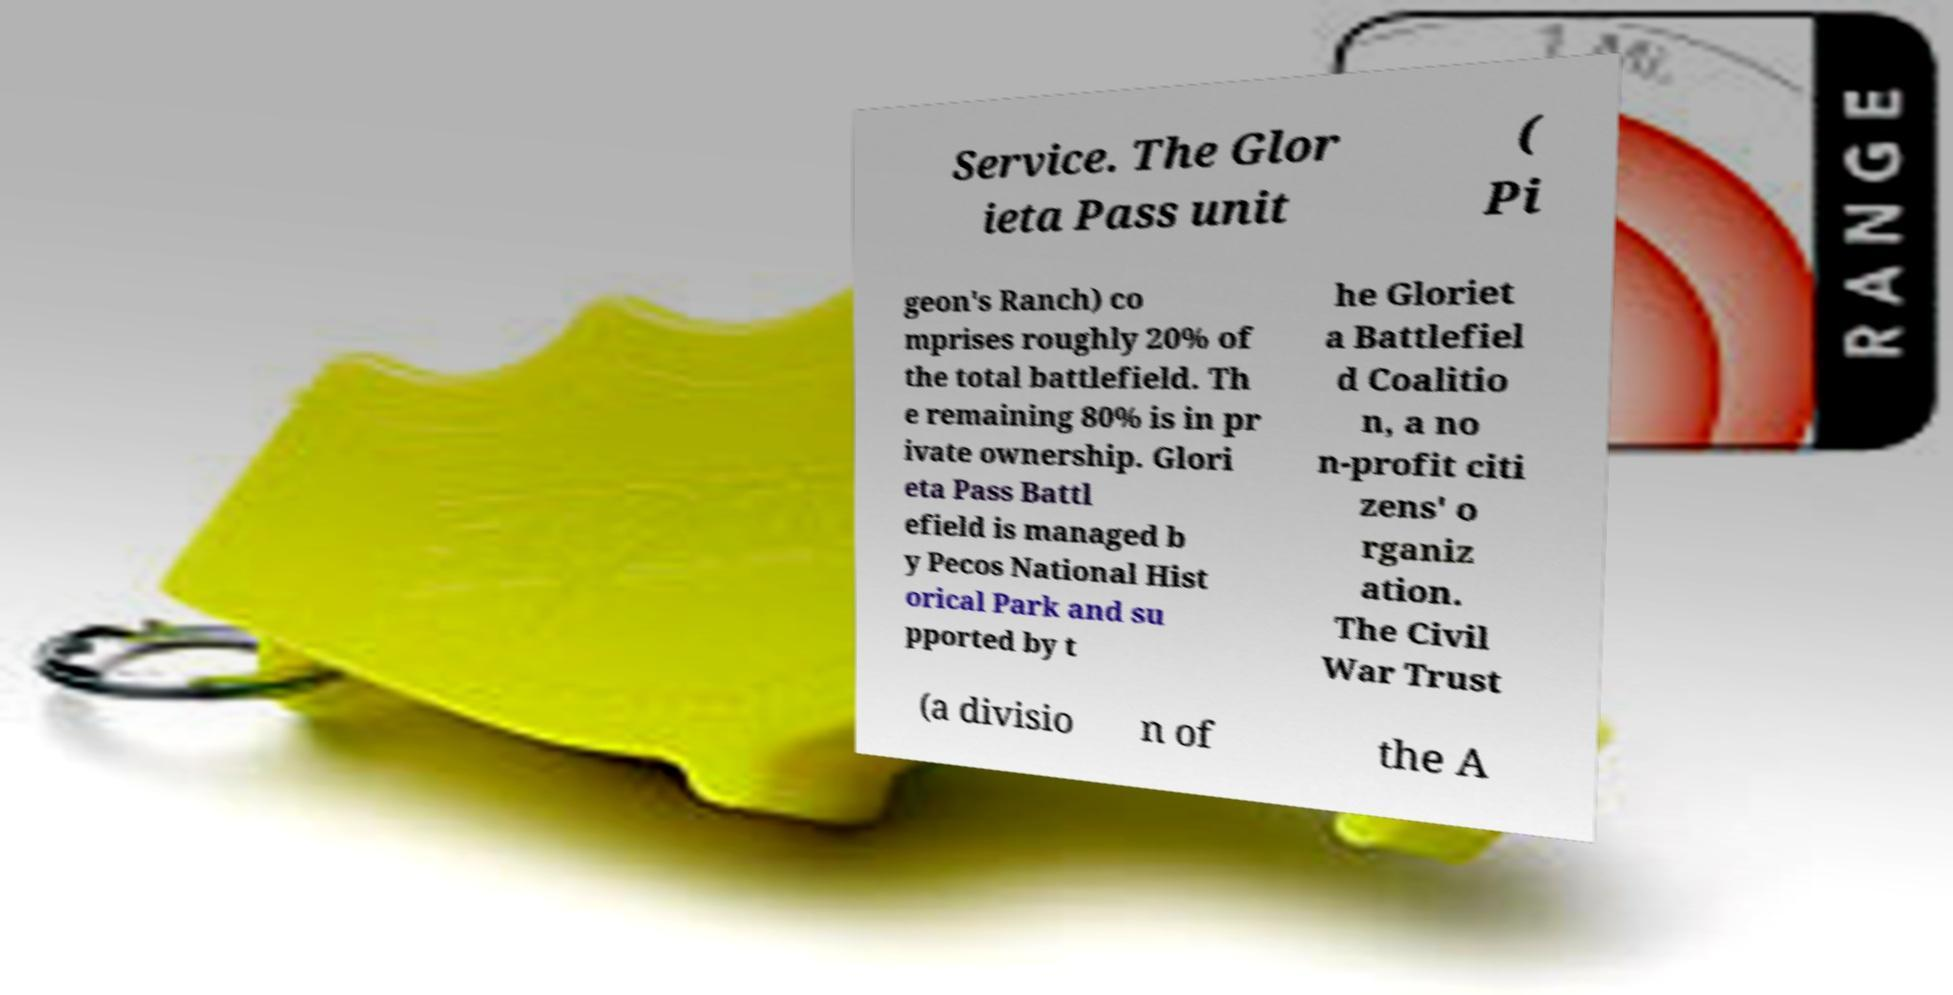I need the written content from this picture converted into text. Can you do that? Service. The Glor ieta Pass unit ( Pi geon's Ranch) co mprises roughly 20% of the total battlefield. Th e remaining 80% is in pr ivate ownership. Glori eta Pass Battl efield is managed b y Pecos National Hist orical Park and su pported by t he Gloriet a Battlefiel d Coalitio n, a no n-profit citi zens' o rganiz ation. The Civil War Trust (a divisio n of the A 